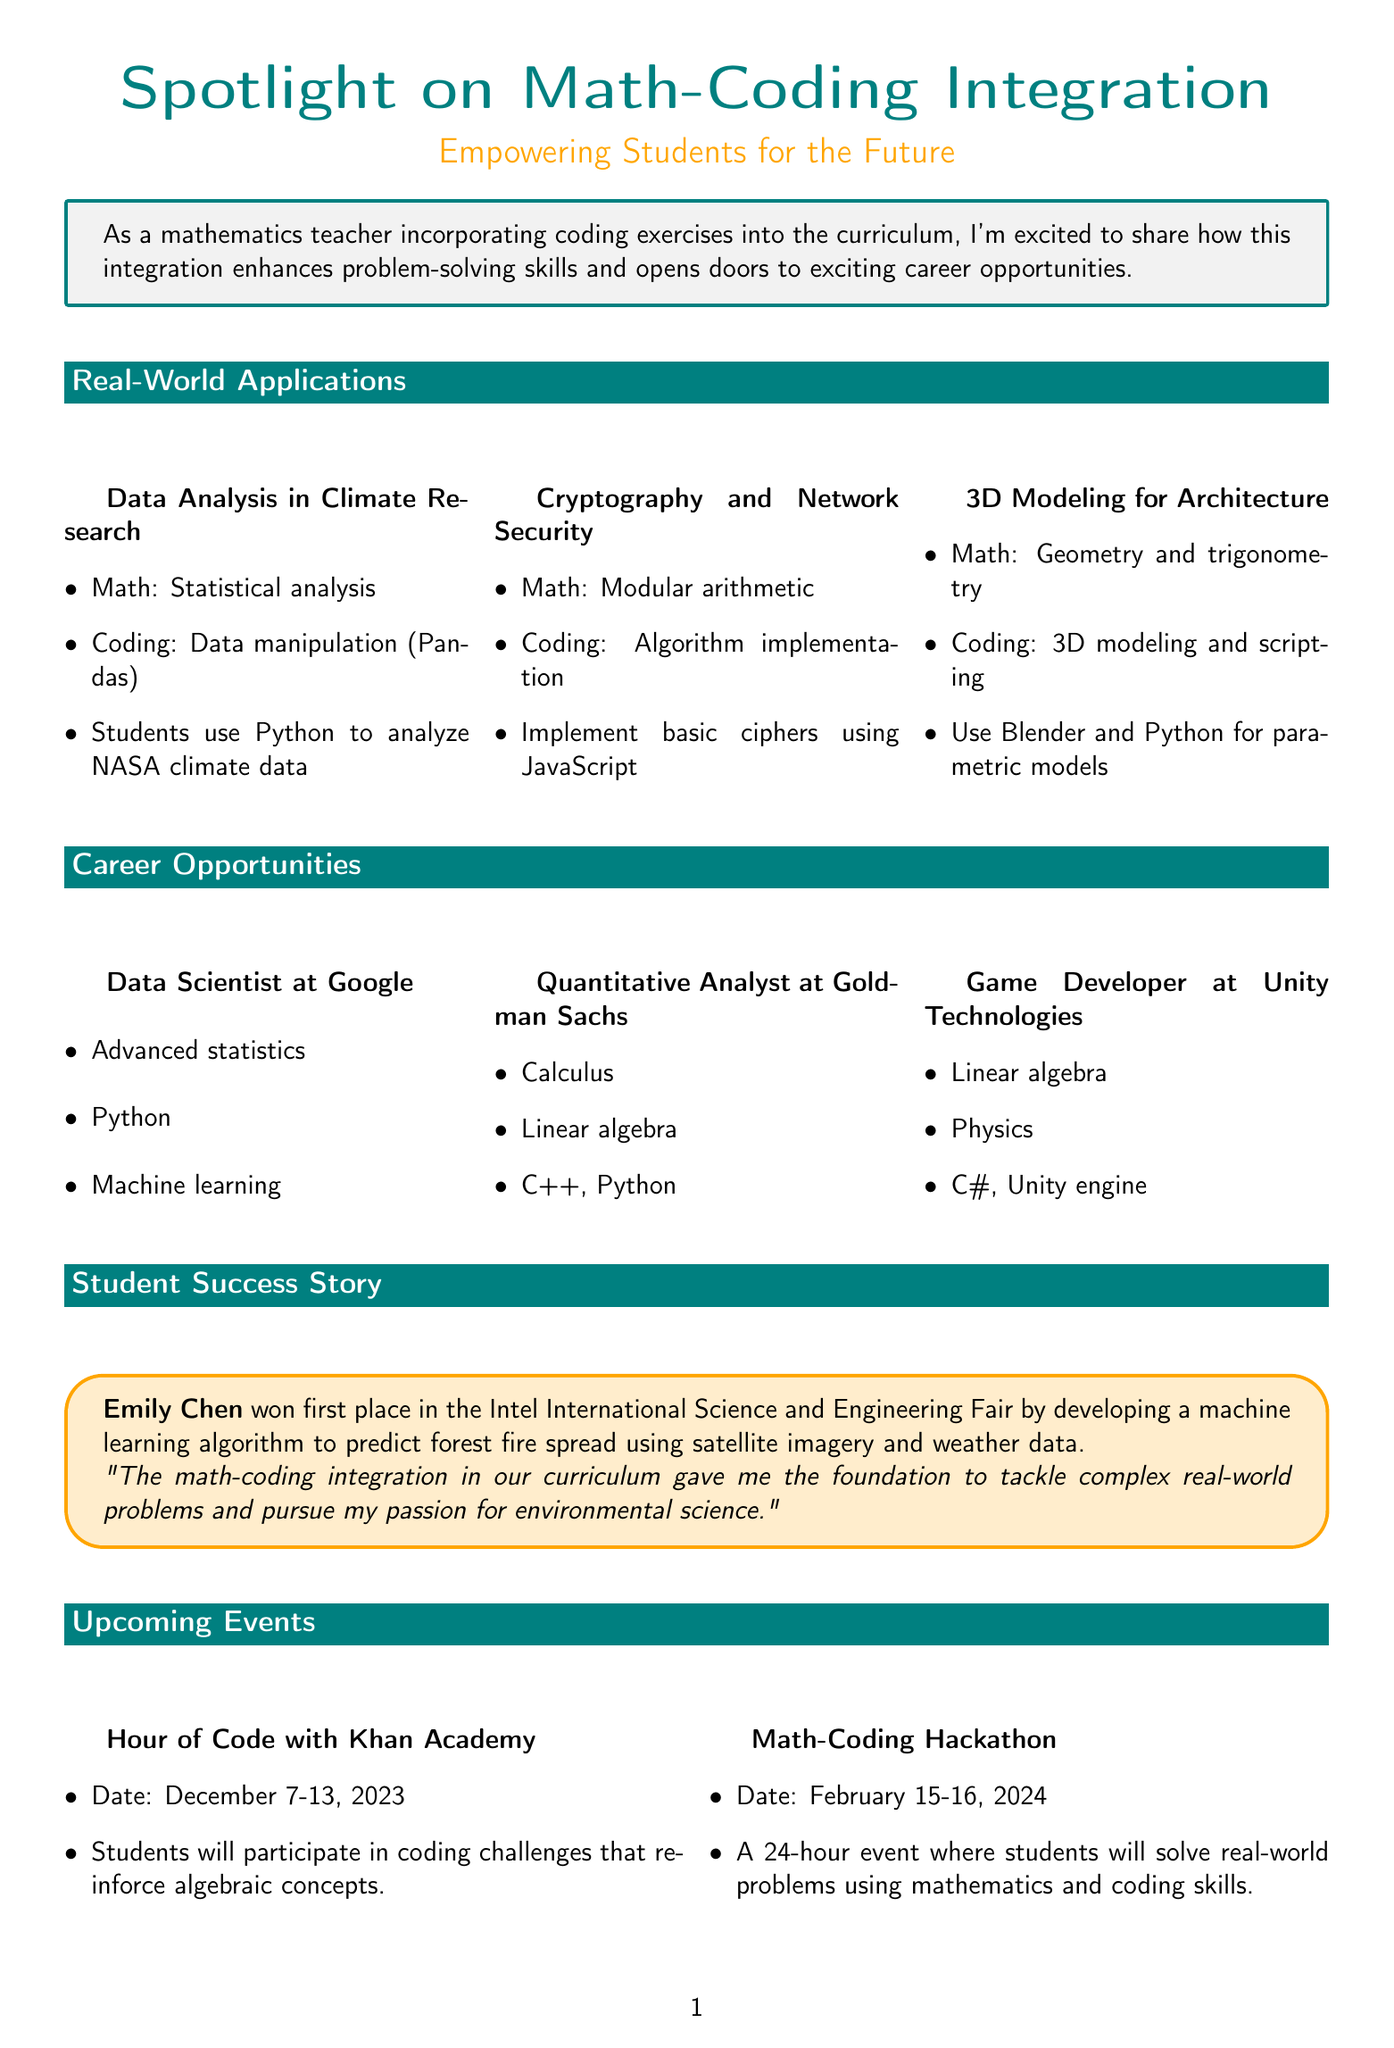What is the title of the newsletter? The title of the newsletter is indicated at the beginning of the document.
Answer: Spotlight on Math-Coding Integration: Empowering Students for the Future Who won first place in the Intel International Science and Engineering Fair? The newsletter highlights a student success story, mentioning the winner's name.
Answer: Emily Chen What is the date of the "Hour of Code with Khan Academy"? The document provides a specific date for this upcoming event.
Answer: December 7-13, 2023 Name one coding skill needed for the "Data Scientist at Google" position. The newsletter lists required skills for each career opportunity, including coding skills.
Answer: Python What mathematical concept is applied in "Cryptography and Network Security"? This section describes the math concepts linked to each real-world application.
Answer: Modular arithmetic How many career opportunities are mentioned in the newsletter? The document includes a list of different career opportunities.
Answer: Three What programming language is used for 3D modeling in architecture? The description of the real-world application outlines the coding skills required.
Answer: Python What event is scheduled for February 15-16, 2024? The document specifies different upcoming events along with their dates.
Answer: Math-Coding Hackathon 